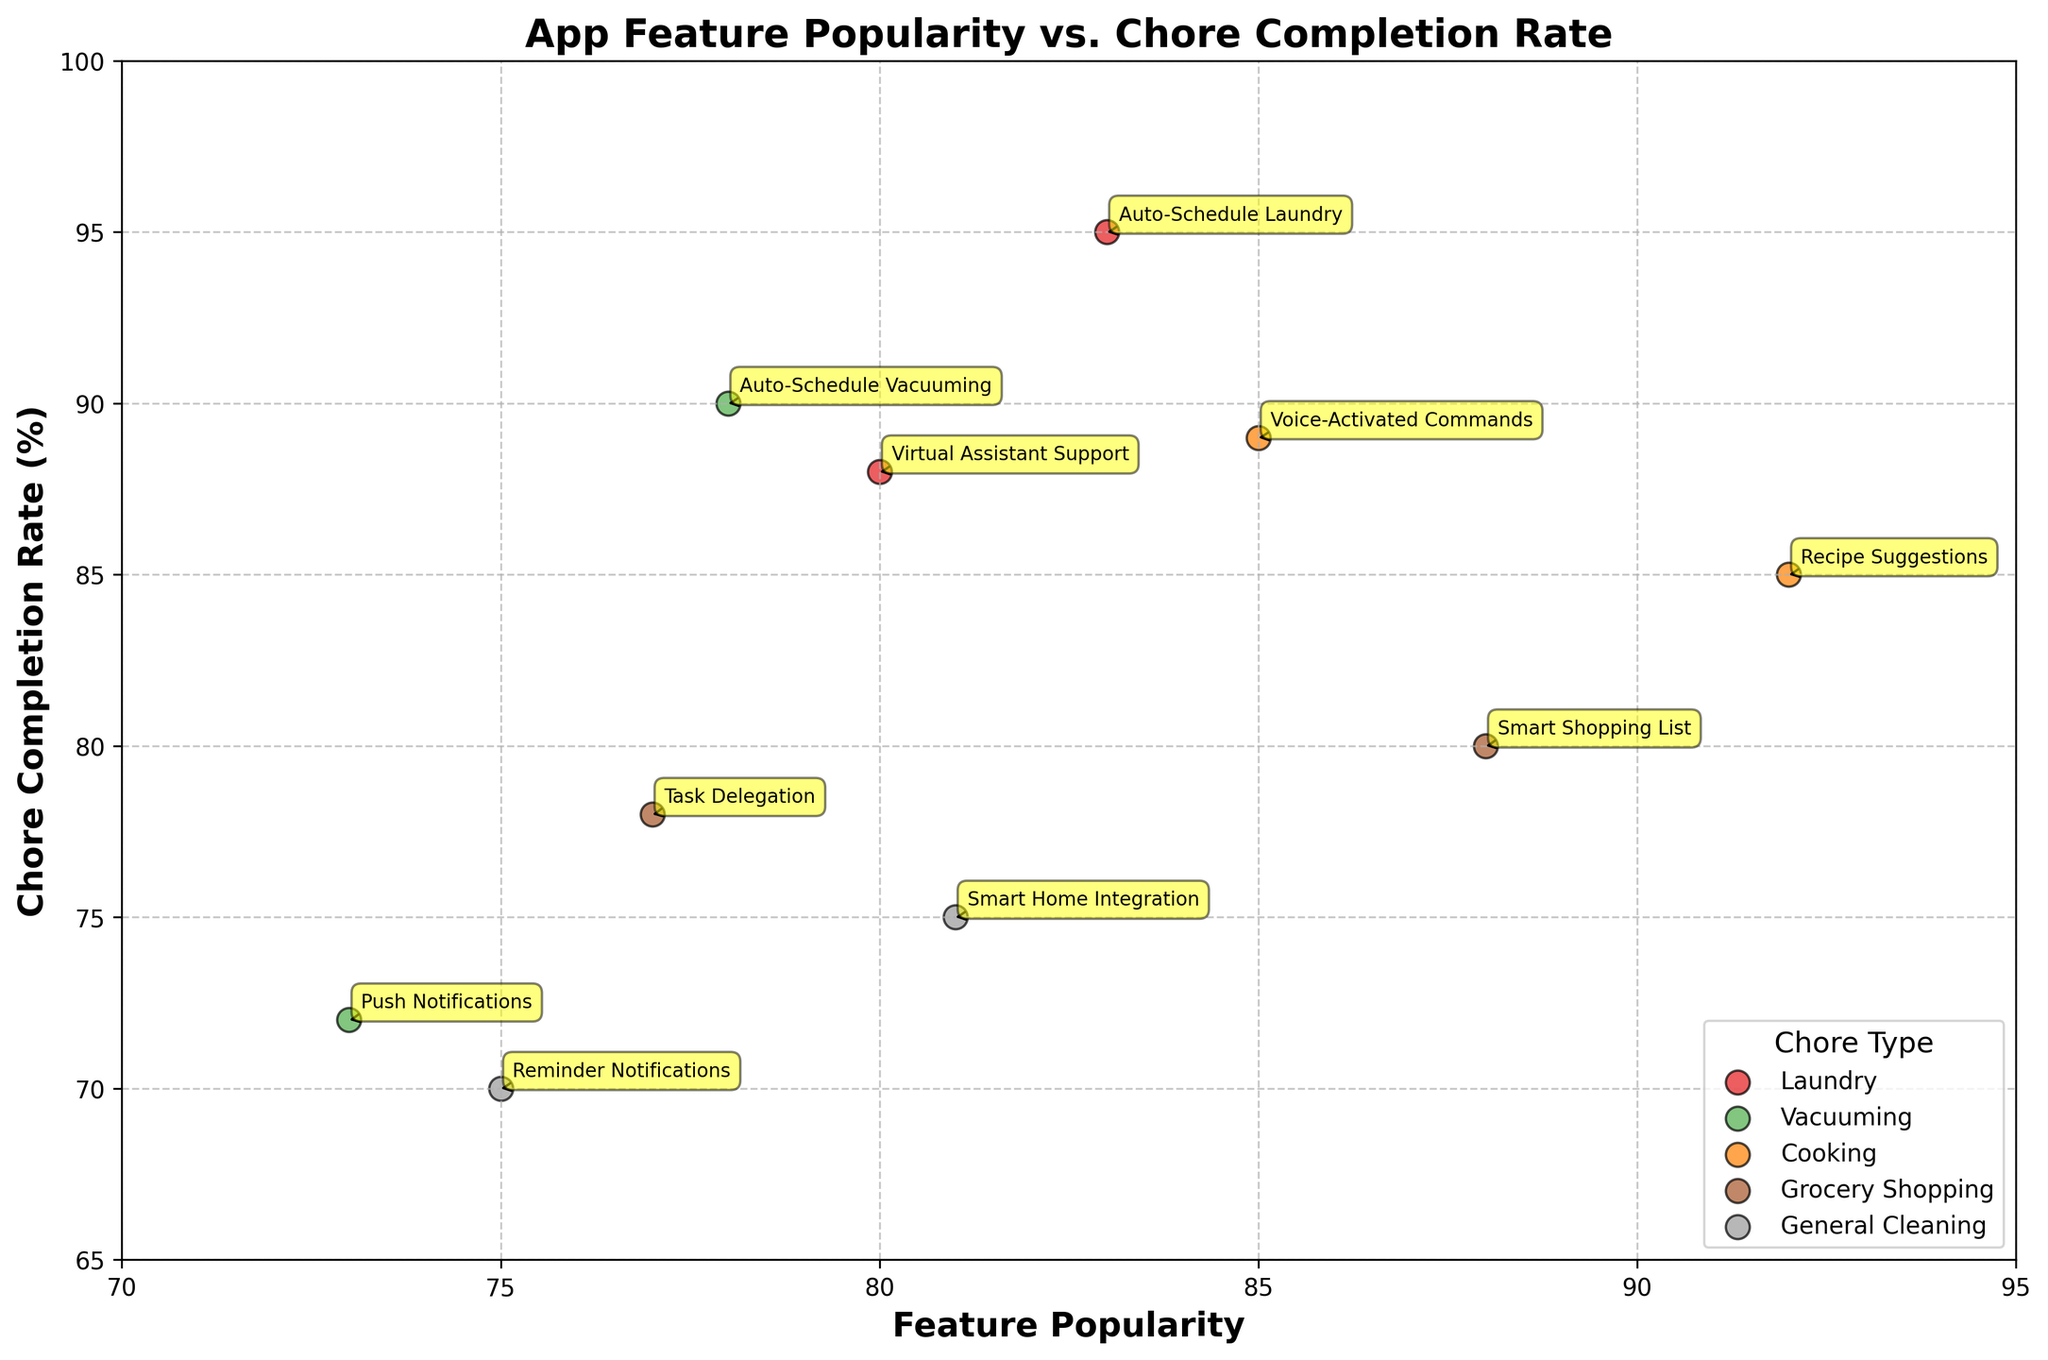What is the title of the plot? The title of the plot is displayed at the top of the figure. By looking at the top of the plot, we can see the title.
Answer: App Feature Popularity vs. Chore Completion Rate What are the labels on the axes? By examining the text next to the horizontal and vertical axes, we can find the labels.
Answer: Feature Popularity on the x-axis and Chore Completion Rate (%) on the y-axis Which app feature has the highest completion rate for Laundry? Look for the app features related to Laundry on the plot and identify which one reaches the highest point on the vertical axis.
Answer: Auto-Schedule Laundry How many different chore types are there? Check the legend of the plot to see the unique chore types listed. Count these unique categories.
Answer: 5 Which chore type has the most app features listed? Observe the legend and identify which chore type appears the most in the plotted points.
Answer: Laundry What is the average completion rate for Grocery Shopping features? Find the data points related to Grocery Shopping and calculate the mean of their completion rates (80 and 78, specifically).
Answer: (80 + 78) / 2 = 79 Which app feature is the least popular for Vacuuming chores? Identify the data points related to Vacuuming and determine which has the lowest value along the horizontal axis.
Answer: Push Notifications Which feature is more popular: Smart Home Integration or Task Delegation? Compare the positions of the two features on the horizontal axis to see which one is further to the right.
Answer: Smart Home Integration What is the difference in completion rate between Reminder Notifications and Auto-Schedule Vacuuming? Find the y-coordinates of these two points and subtract the value of the other.
Answer: 90 - 70 = 20 Are any features common to both Cooking and General Cleaning chores? Examine the plotted points and legend to see if any app features appear in both categories.
Answer: No 